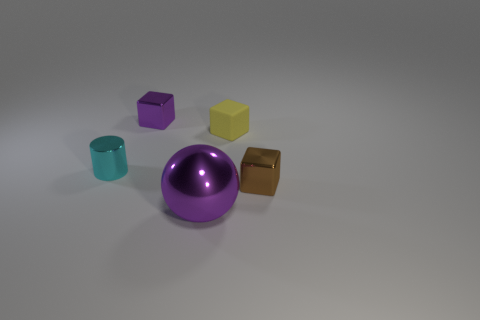There is a block that is both to the right of the shiny sphere and left of the small brown metal object; how big is it?
Offer a very short reply. Small. How many large shiny things have the same color as the metal cylinder?
Your answer should be very brief. 0. There is a thing that is the same color as the sphere; what material is it?
Ensure brevity in your answer.  Metal. What is the tiny purple block made of?
Your response must be concise. Metal. Is the material of the purple thing that is behind the small cylinder the same as the purple ball?
Offer a very short reply. Yes. There is a purple thing that is in front of the cylinder; what is its shape?
Offer a terse response. Sphere. What material is the brown cube that is the same size as the cyan cylinder?
Give a very brief answer. Metal. How many things are purple metallic things behind the tiny brown thing or tiny metal cubes that are in front of the tiny purple block?
Keep it short and to the point. 2. The brown object that is made of the same material as the large ball is what size?
Provide a succinct answer. Small. How many matte objects are either small purple things or brown objects?
Your response must be concise. 0. 